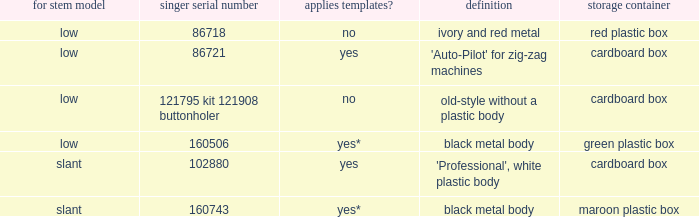What are all the different descriptions for the buttonholer with cardboard box for storage and a low shank type? 'Auto-Pilot' for zig-zag machines, old-style without a plastic body. 